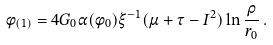Convert formula to latex. <formula><loc_0><loc_0><loc_500><loc_500>\phi _ { ( 1 ) } = 4 G _ { 0 } \alpha ( \phi _ { 0 } ) \xi ^ { - 1 } ( \mu + \tau - I ^ { 2 } ) \ln \frac { \rho } { r _ { 0 } } \, .</formula> 